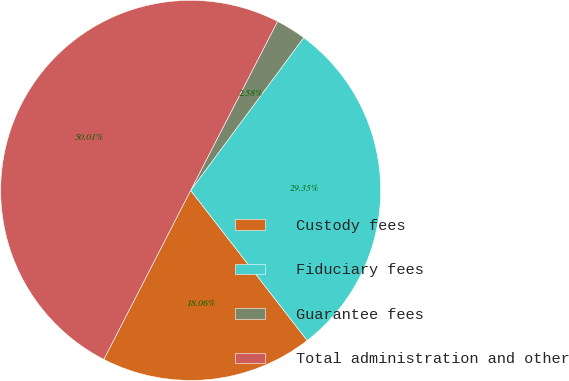Convert chart. <chart><loc_0><loc_0><loc_500><loc_500><pie_chart><fcel>Custody fees<fcel>Fiduciary fees<fcel>Guarantee fees<fcel>Total administration and other<nl><fcel>18.06%<fcel>29.35%<fcel>2.58%<fcel>50.0%<nl></chart> 